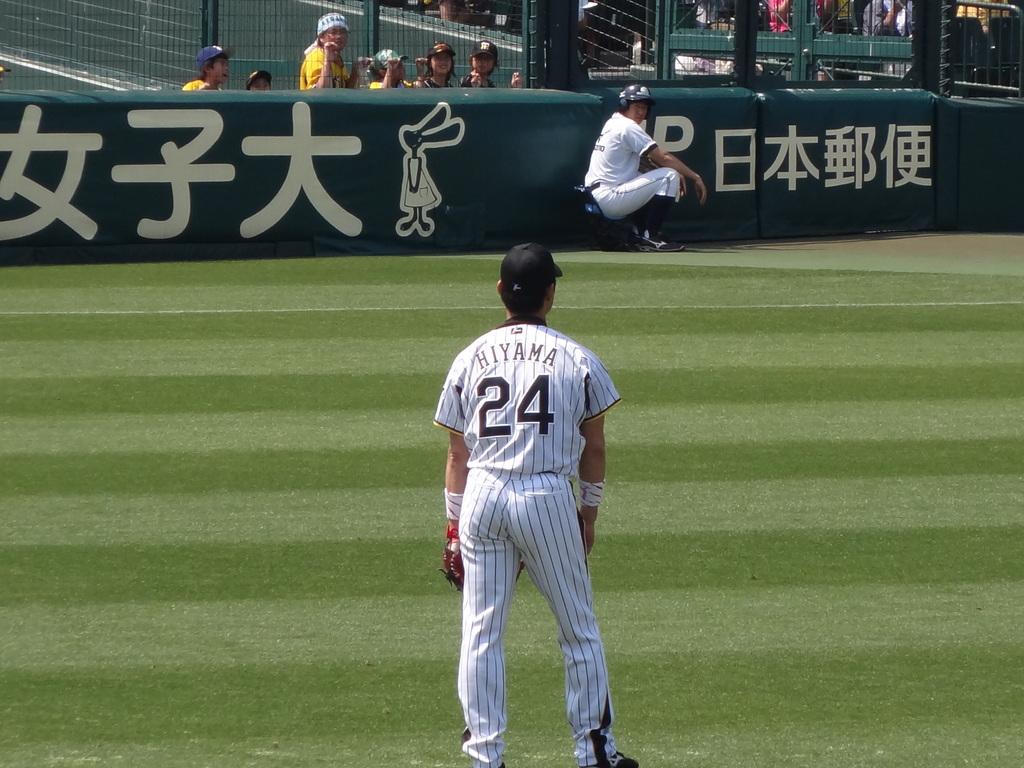Who is player 24?
Ensure brevity in your answer.  Hiyama. What number is the player wearing?
Provide a succinct answer. 24. 